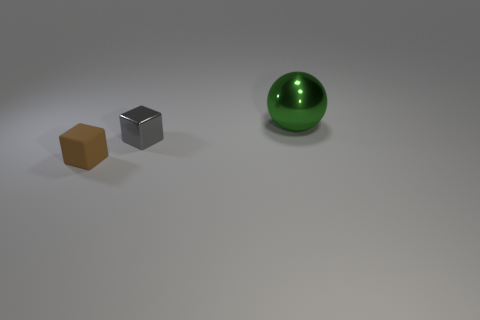Add 3 tiny green shiny cylinders. How many objects exist? 6 Subtract 0 green blocks. How many objects are left? 3 Subtract all cubes. How many objects are left? 1 Subtract all small gray rubber cylinders. Subtract all large green shiny balls. How many objects are left? 2 Add 3 tiny brown things. How many tiny brown things are left? 4 Add 1 green matte cubes. How many green matte cubes exist? 1 